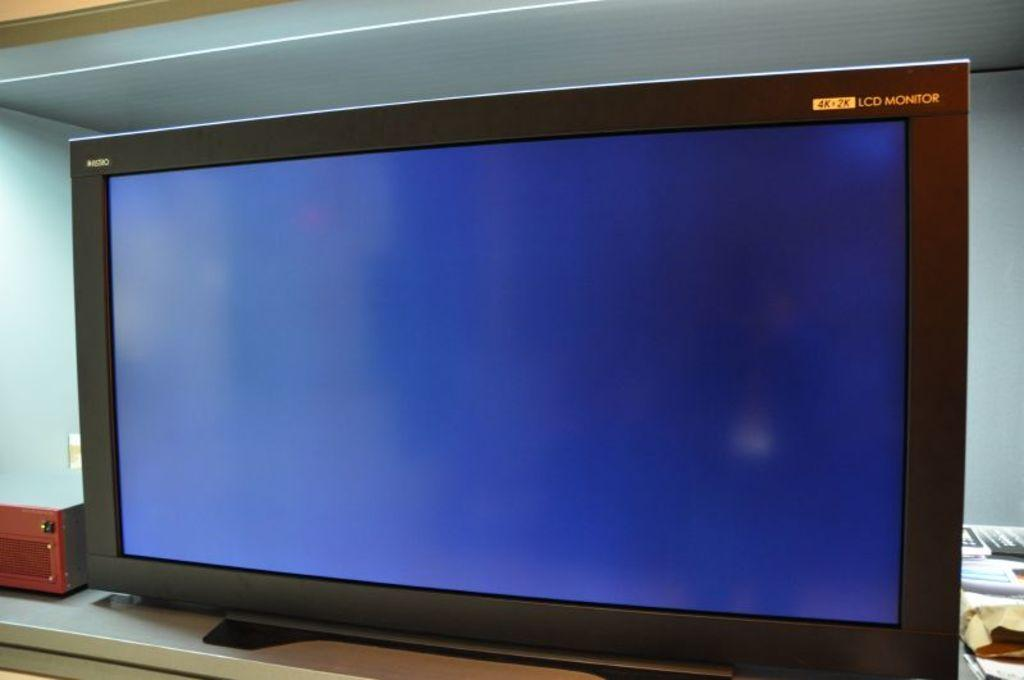Provide a one-sentence caption for the provided image. A black 4k+2k LCD monitor with a blue screen. 